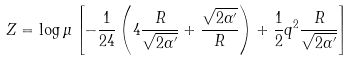<formula> <loc_0><loc_0><loc_500><loc_500>Z = \log \mu \left [ - \frac { 1 } { 2 4 } \left ( 4 \frac { R } { \sqrt { 2 \alpha ^ { \prime } } } + \frac { \sqrt { 2 \alpha ^ { \prime } } } { R } \right ) + \frac { 1 } { 2 } q ^ { 2 } \frac { R } { \sqrt { 2 \alpha ^ { \prime } } } \right ]</formula> 